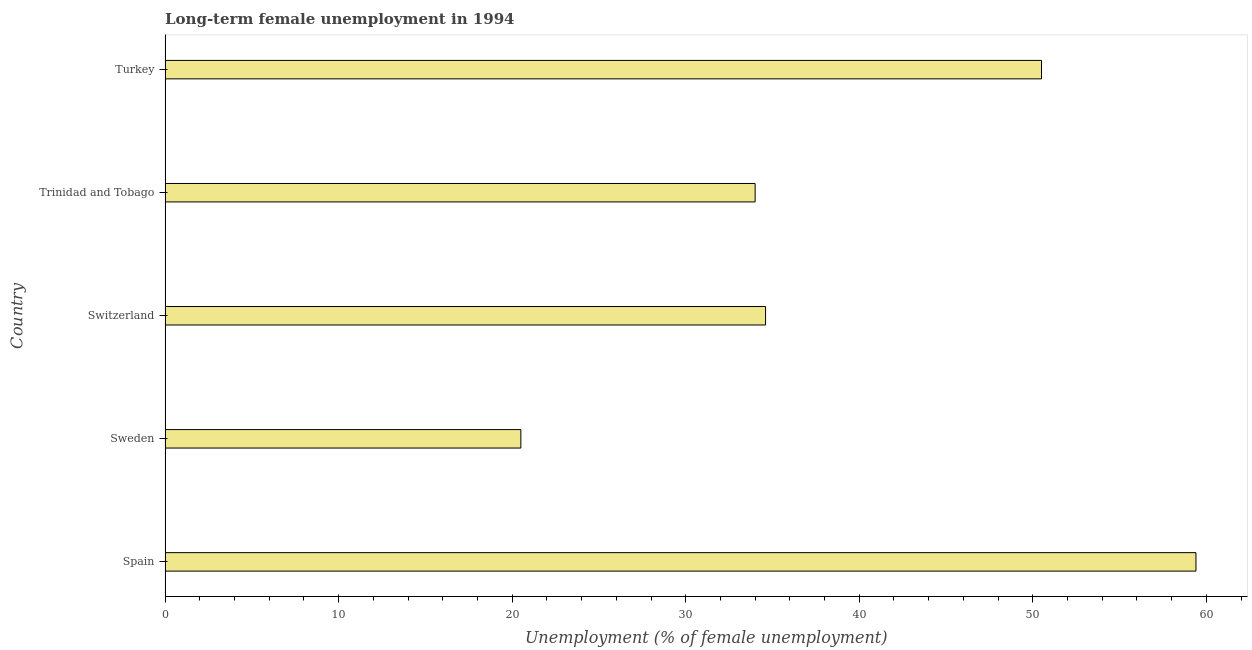Does the graph contain grids?
Offer a terse response. No. What is the title of the graph?
Your answer should be compact. Long-term female unemployment in 1994. What is the label or title of the X-axis?
Make the answer very short. Unemployment (% of female unemployment). What is the long-term female unemployment in Switzerland?
Make the answer very short. 34.6. Across all countries, what is the maximum long-term female unemployment?
Your answer should be very brief. 59.4. In which country was the long-term female unemployment minimum?
Provide a succinct answer. Sweden. What is the sum of the long-term female unemployment?
Provide a succinct answer. 199. What is the difference between the long-term female unemployment in Trinidad and Tobago and Turkey?
Make the answer very short. -16.5. What is the average long-term female unemployment per country?
Ensure brevity in your answer.  39.8. What is the median long-term female unemployment?
Provide a short and direct response. 34.6. What is the ratio of the long-term female unemployment in Trinidad and Tobago to that in Turkey?
Your response must be concise. 0.67. What is the difference between the highest and the second highest long-term female unemployment?
Your answer should be very brief. 8.9. Is the sum of the long-term female unemployment in Sweden and Trinidad and Tobago greater than the maximum long-term female unemployment across all countries?
Provide a succinct answer. No. What is the difference between the highest and the lowest long-term female unemployment?
Provide a short and direct response. 38.9. Are all the bars in the graph horizontal?
Offer a very short reply. Yes. Are the values on the major ticks of X-axis written in scientific E-notation?
Provide a short and direct response. No. What is the Unemployment (% of female unemployment) in Spain?
Make the answer very short. 59.4. What is the Unemployment (% of female unemployment) in Sweden?
Your response must be concise. 20.5. What is the Unemployment (% of female unemployment) of Switzerland?
Your answer should be very brief. 34.6. What is the Unemployment (% of female unemployment) in Trinidad and Tobago?
Give a very brief answer. 34. What is the Unemployment (% of female unemployment) in Turkey?
Keep it short and to the point. 50.5. What is the difference between the Unemployment (% of female unemployment) in Spain and Sweden?
Make the answer very short. 38.9. What is the difference between the Unemployment (% of female unemployment) in Spain and Switzerland?
Provide a succinct answer. 24.8. What is the difference between the Unemployment (% of female unemployment) in Spain and Trinidad and Tobago?
Make the answer very short. 25.4. What is the difference between the Unemployment (% of female unemployment) in Sweden and Switzerland?
Your answer should be very brief. -14.1. What is the difference between the Unemployment (% of female unemployment) in Sweden and Turkey?
Keep it short and to the point. -30. What is the difference between the Unemployment (% of female unemployment) in Switzerland and Turkey?
Your response must be concise. -15.9. What is the difference between the Unemployment (% of female unemployment) in Trinidad and Tobago and Turkey?
Your response must be concise. -16.5. What is the ratio of the Unemployment (% of female unemployment) in Spain to that in Sweden?
Make the answer very short. 2.9. What is the ratio of the Unemployment (% of female unemployment) in Spain to that in Switzerland?
Provide a short and direct response. 1.72. What is the ratio of the Unemployment (% of female unemployment) in Spain to that in Trinidad and Tobago?
Your response must be concise. 1.75. What is the ratio of the Unemployment (% of female unemployment) in Spain to that in Turkey?
Your answer should be very brief. 1.18. What is the ratio of the Unemployment (% of female unemployment) in Sweden to that in Switzerland?
Your answer should be very brief. 0.59. What is the ratio of the Unemployment (% of female unemployment) in Sweden to that in Trinidad and Tobago?
Give a very brief answer. 0.6. What is the ratio of the Unemployment (% of female unemployment) in Sweden to that in Turkey?
Keep it short and to the point. 0.41. What is the ratio of the Unemployment (% of female unemployment) in Switzerland to that in Turkey?
Ensure brevity in your answer.  0.69. What is the ratio of the Unemployment (% of female unemployment) in Trinidad and Tobago to that in Turkey?
Your answer should be very brief. 0.67. 